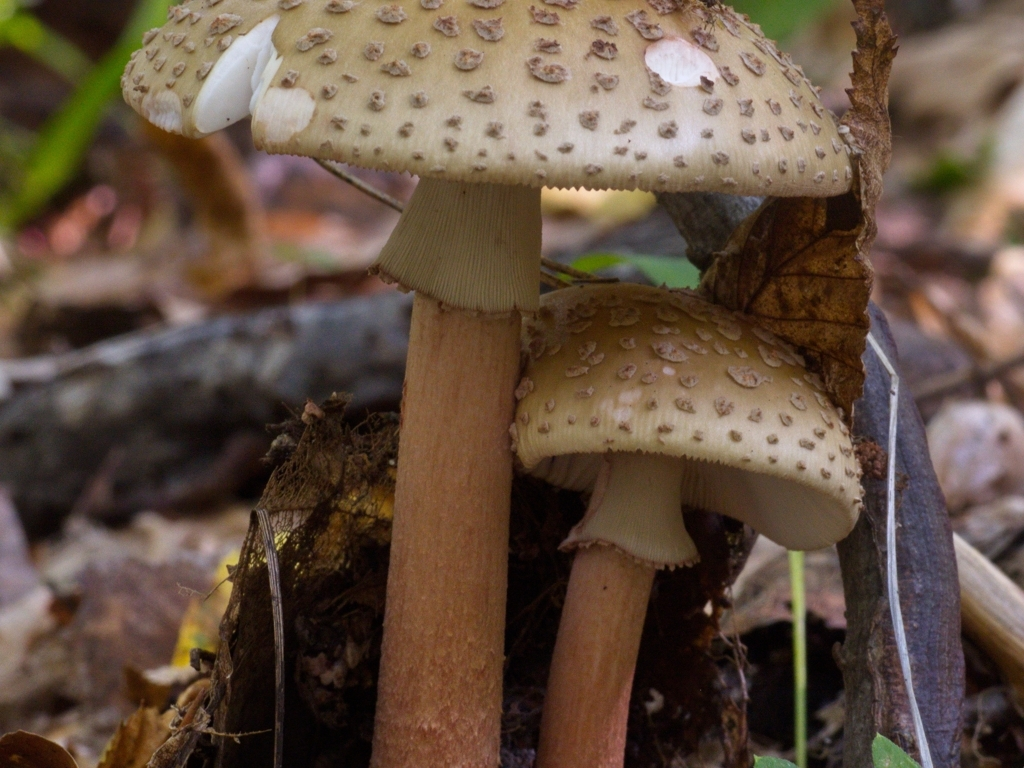What is the focus of the image?
A. The focus is on the mushrooms in the foreground.
B. The focus is evenly distributed.
C. The focus is on the flowers in the background.
D. The focus is on the trees in the middle ground.
Answer with the option's letter from the given choices directly.
 A. 